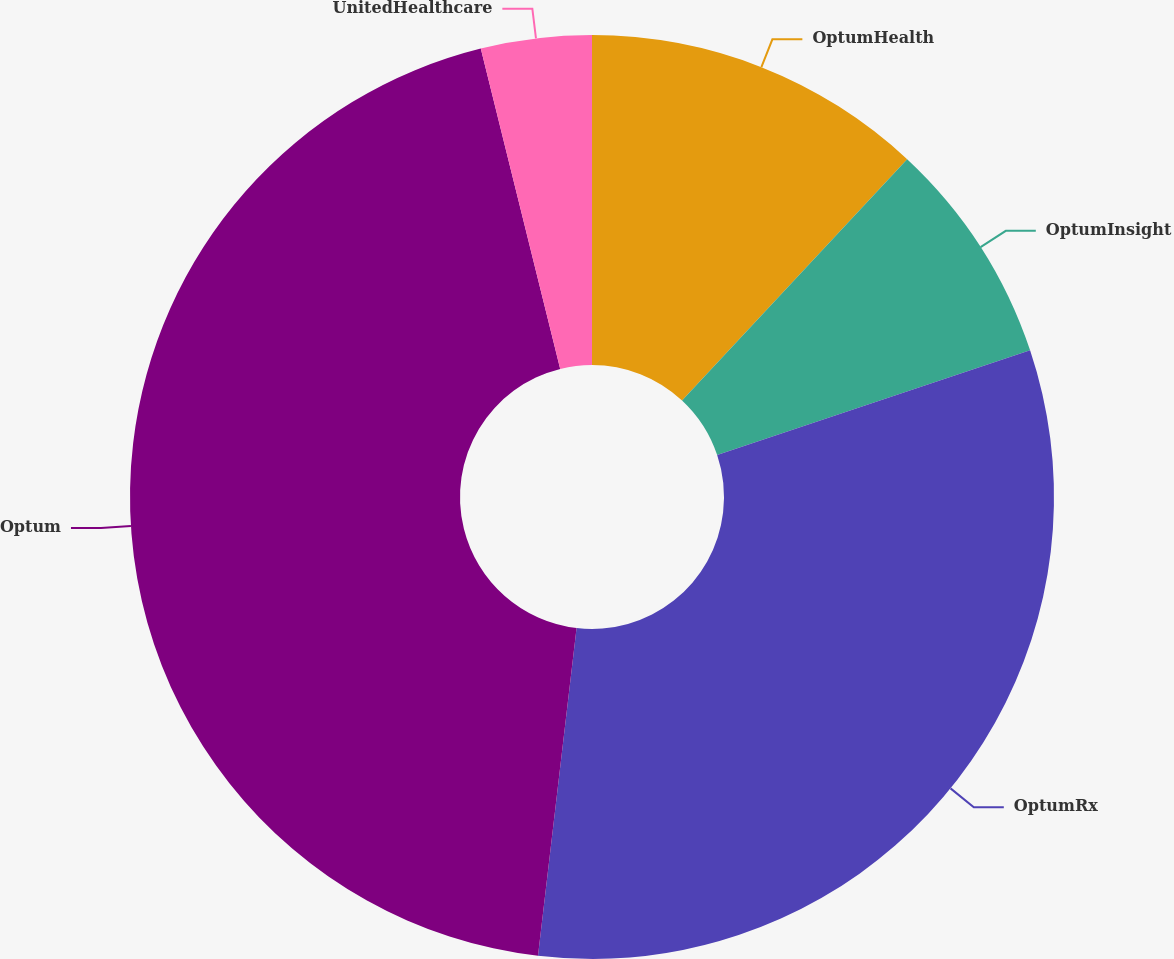<chart> <loc_0><loc_0><loc_500><loc_500><pie_chart><fcel>OptumHealth<fcel>OptumInsight<fcel>OptumRx<fcel>Optum<fcel>UnitedHealthcare<nl><fcel>11.95%<fcel>7.91%<fcel>32.01%<fcel>44.27%<fcel>3.87%<nl></chart> 